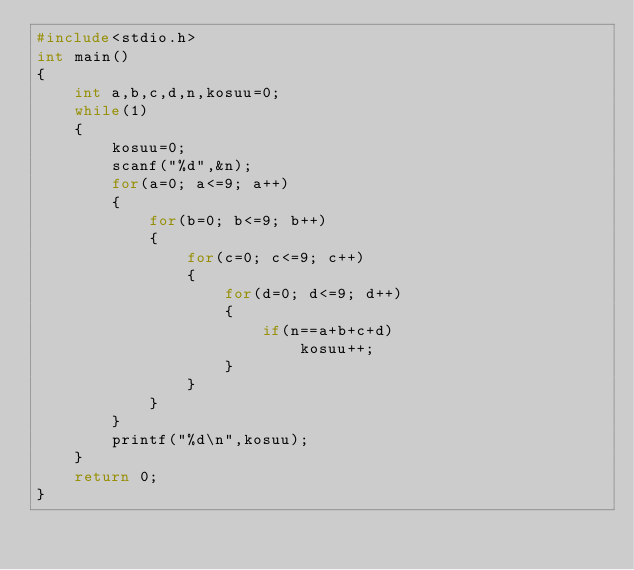<code> <loc_0><loc_0><loc_500><loc_500><_C_>#include<stdio.h>
int main()
{
	int a,b,c,d,n,kosuu=0;
	while(1)
	{
		kosuu=0;
		scanf("%d",&n);
		for(a=0; a<=9; a++)
		{
			for(b=0; b<=9; b++)
			{
				for(c=0; c<=9; c++)
				{
					for(d=0; d<=9; d++)
					{
						if(n==a+b+c+d)
							kosuu++;
					}
				}
			}
		}
		printf("%d\n",kosuu);
	}
	return 0;
}</code> 